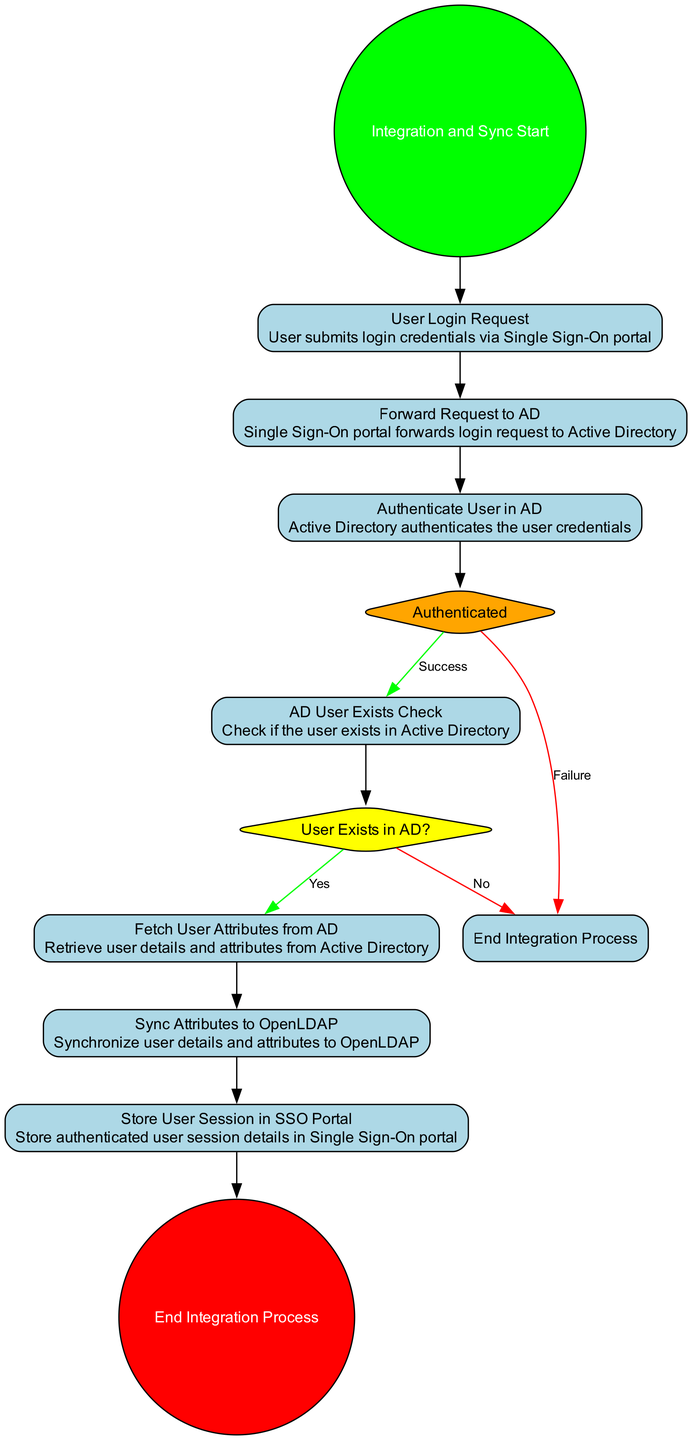What is the starting node of the activity diagram? The starting node of the diagram, which signifies the beginning of the process, is labeled "Integration and Sync Start."
Answer: Integration and Sync Start How many actions are there in the diagram? The diagram contains a total of six actions that represent specific tasks in the activity flow.
Answer: 6 What is the result of a successful user authentication in Active Directory? If the user is successfully authenticated, the flow progresses to the "AD User Exists Check" action.
Answer: AD User Exists Check What happens if the user does not exist in Active Directory? If the user does not exist, the process terminates, leading directly to the "End Integration Process."
Answer: End Integration Process What is the outcome after synchronizing attributes to OpenLDAP? After synchronizing the attributes, the next action is to "Store User Session in SSO Portal."
Answer: Store User Session in SSO Portal How many decision points are present in the diagram? The activity diagram includes two decision points: "User Exists in AD?" and "Authenticated."
Answer: 2 Which action follows the "Fetch User Attributes from AD"? Following the completion of the action "Fetch User Attributes from AD," the next step in the flow is to "Sync Attributes to OpenLDAP."
Answer: Sync Attributes to OpenLDAP What happens if the user fails to authenticate? If the user fails to authenticate, the process concludes by leading to the "End Integration Process."
Answer: End Integration Process What color represents the decision nodes in the diagram? The decision nodes are represented in yellow color, distinguishing them from other node types.
Answer: Yellow 